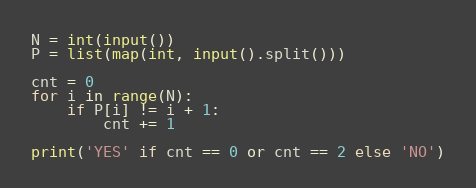<code> <loc_0><loc_0><loc_500><loc_500><_Python_>N = int(input())
P = list(map(int, input().split()))

cnt = 0
for i in range(N):
    if P[i] != i + 1:
        cnt += 1

print('YES' if cnt == 0 or cnt == 2 else 'NO')</code> 